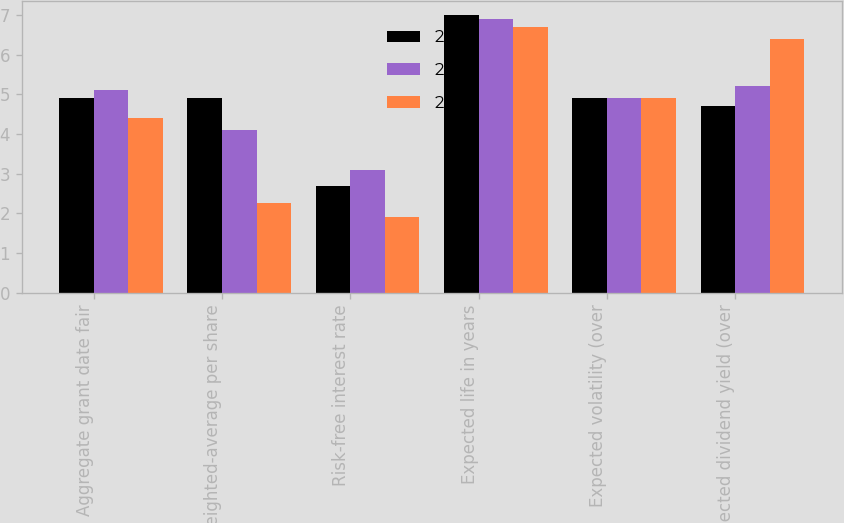<chart> <loc_0><loc_0><loc_500><loc_500><stacked_bar_chart><ecel><fcel>Aggregate grant date fair<fcel>Weighted-average per share<fcel>Risk-free interest rate<fcel>Expected life in years<fcel>Expected volatility (over<fcel>Expected dividend yield (over<nl><fcel>2010<fcel>4.9<fcel>4.9<fcel>2.7<fcel>7<fcel>4.9<fcel>4.7<nl><fcel>2011<fcel>5.1<fcel>4.09<fcel>3.1<fcel>6.9<fcel>4.9<fcel>5.2<nl><fcel>2009<fcel>4.4<fcel>2.27<fcel>1.9<fcel>6.7<fcel>4.9<fcel>6.4<nl></chart> 